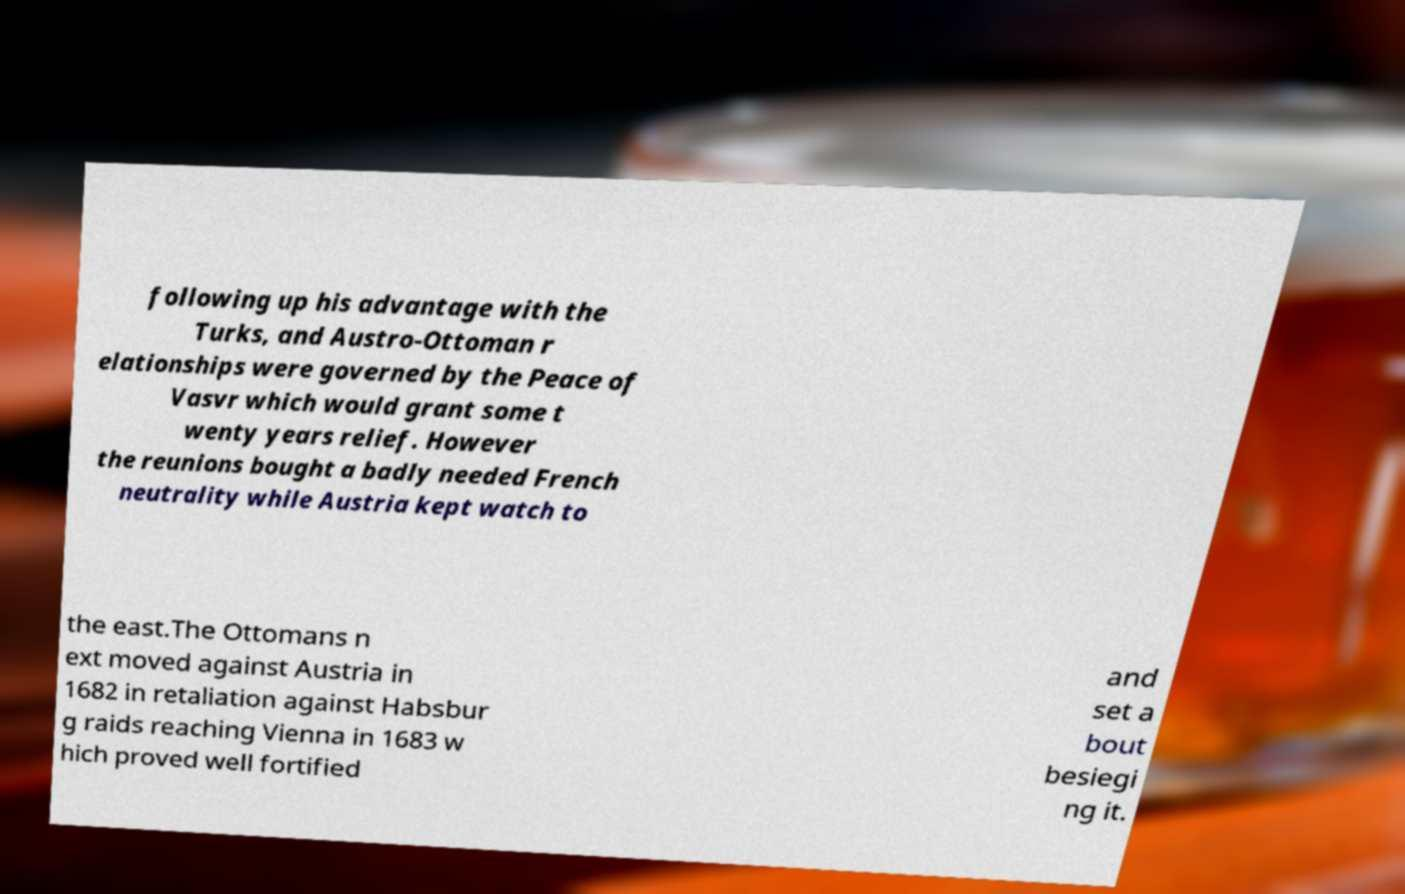Could you extract and type out the text from this image? following up his advantage with the Turks, and Austro-Ottoman r elationships were governed by the Peace of Vasvr which would grant some t wenty years relief. However the reunions bought a badly needed French neutrality while Austria kept watch to the east.The Ottomans n ext moved against Austria in 1682 in retaliation against Habsbur g raids reaching Vienna in 1683 w hich proved well fortified and set a bout besiegi ng it. 